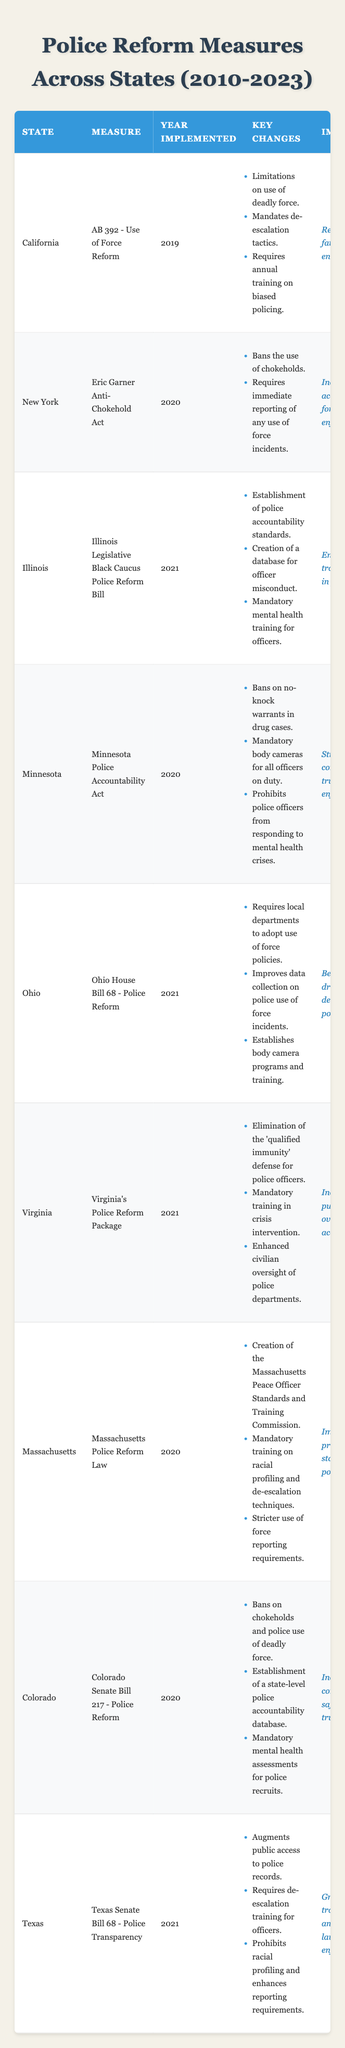What police reform measure was implemented by California? The table lists "AB 392 - Use of Force Reform" as the police reform measure implemented by California.
Answer: AB 392 - Use of Force Reform In what year was the Eric Garner Anti-Chokehold Act implemented in New York? The table indicates that New York implemented the Eric Garner Anti-Chokehold Act in 2020.
Answer: 2020 What are the key changes included in the Illinois Legislative Black Caucus Police Reform Bill? The key changes listed in the table for the bill include the establishment of police accountability standards, the creation of a database for officer misconduct, and mandatory mental health training for officers.
Answer: Police accountability standards, officer misconduct database, mental health training Which state implemented police reforms banning chokeholds and police use of deadly force? The table shows that both Colorado and New York have measures banning chokeholds, while Colorado specifically mentions banning police use of deadly force.
Answer: Colorado How many police reform measures were implemented in 2021? By counting the years in the table, there are five police reform measures implemented in 2021: Illinois, Ohio, Virginia, Texas, and Minnesota.
Answer: 5 Was the Minnesota Police Accountability Act focused on community trust? The impact of the Minnesota Police Accountability Act, as seen in the table, states that its impact was to strengthen community trust in law enforcement. Thus, the statement is true.
Answer: Yes What is the impact of the Texas Senate Bill 68 on transparency? The table states that the impact of Texas Senate Bill 68 is greater transparency and trust in law enforcement.
Answer: Greater transparency and trust Which state's reform package eliminated the 'qualified immunity' defense for police officers? According to the table, Virginia's Police Reform Package eliminated the 'qualified immunity' defense for police officers.
Answer: Virginia Are there any states that required mandatory training for officers regarding racial profiling? The table indicates that Massachusetts Police Reform Law includes mandatory training on racial profiling, confirming that there is at least one state with such a requirement.
Answer: Yes Find the average number of key changes in the police reform measures implemented in Minnesota and Texas. Minnesota has three key changes listed, and Texas has three as well. Adding them gives 6 changes total, and dividing by 2 (the two states) yields an average of 3 key changes.
Answer: 3 